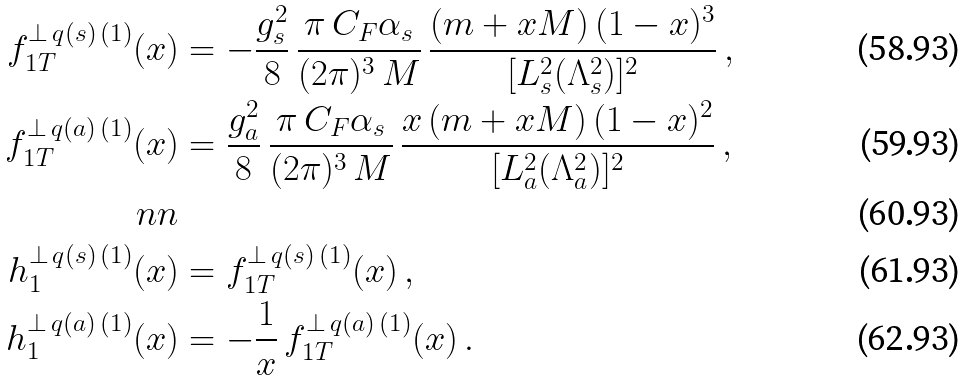Convert formula to latex. <formula><loc_0><loc_0><loc_500><loc_500>f _ { 1 T } ^ { \perp \, q ( s ) \, ( 1 ) } ( x ) & = - \frac { g _ { s } ^ { 2 } } { 8 } \, \frac { \pi \, C _ { F } \alpha _ { s } } { ( 2 \pi ) ^ { 3 } \, M } \, \frac { ( m + x M ) \, ( 1 - x ) ^ { 3 } } { [ L _ { s } ^ { 2 } ( \Lambda _ { s } ^ { 2 } ) ] ^ { 2 } } \, , \\ f _ { 1 T } ^ { \perp \, q ( a ) \, ( 1 ) } ( x ) & = \frac { g _ { a } ^ { 2 } } { 8 } \, \frac { \pi \, C _ { F } \alpha _ { s } } { ( 2 \pi ) ^ { 3 } \, M } \, \frac { x \, ( m + x M ) \, ( 1 - x ) ^ { 2 } } { [ L _ { a } ^ { 2 } ( \Lambda _ { a } ^ { 2 } ) ] ^ { 2 } } \, , \\ \ n n \\ h _ { 1 } ^ { \perp \, q ( s ) \, ( 1 ) } ( x ) & = f _ { 1 T } ^ { \perp \, q ( s ) \, ( 1 ) } ( x ) \, , \\ h _ { 1 } ^ { \perp \, q ( a ) \, ( 1 ) } ( x ) & = - \frac { 1 } { x } \, f _ { 1 T } ^ { \perp \, q ( a ) \, ( 1 ) } ( x ) \, .</formula> 